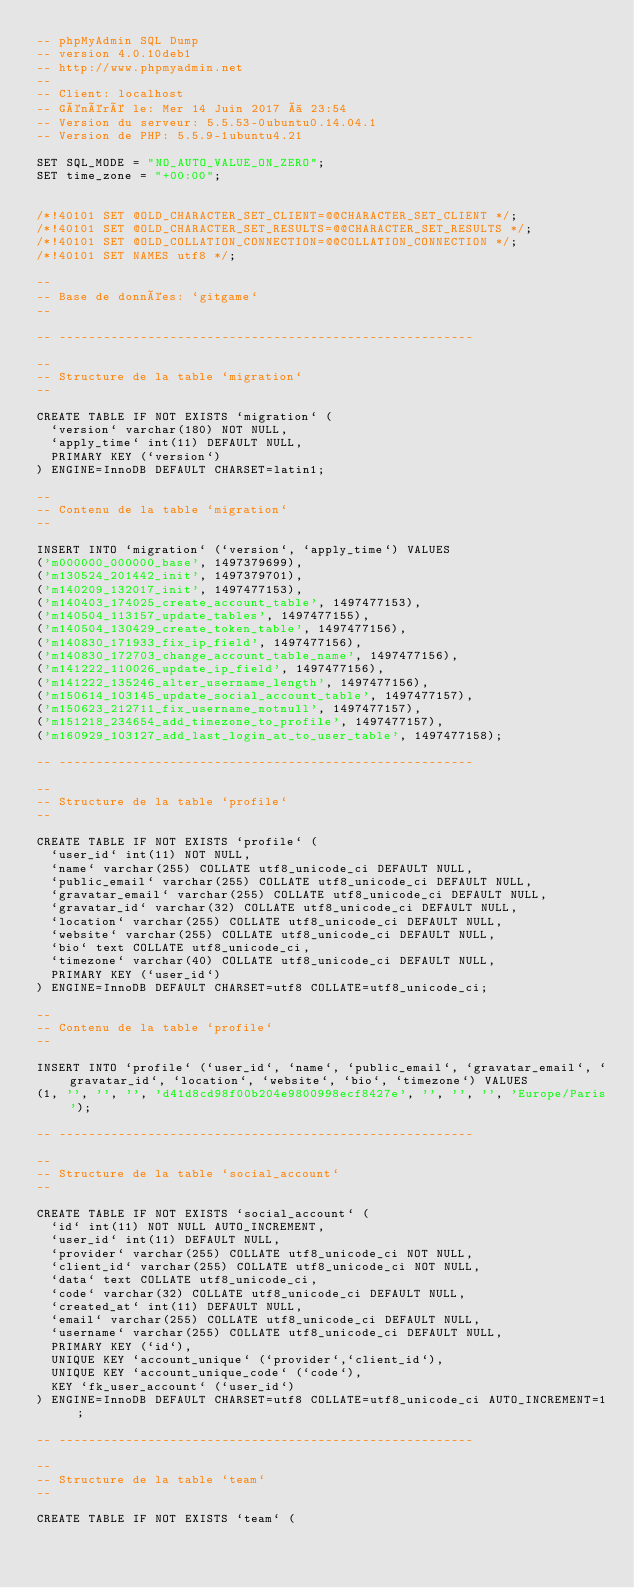<code> <loc_0><loc_0><loc_500><loc_500><_SQL_>-- phpMyAdmin SQL Dump
-- version 4.0.10deb1
-- http://www.phpmyadmin.net
--
-- Client: localhost
-- Généré le: Mer 14 Juin 2017 à 23:54
-- Version du serveur: 5.5.53-0ubuntu0.14.04.1
-- Version de PHP: 5.5.9-1ubuntu4.21

SET SQL_MODE = "NO_AUTO_VALUE_ON_ZERO";
SET time_zone = "+00:00";


/*!40101 SET @OLD_CHARACTER_SET_CLIENT=@@CHARACTER_SET_CLIENT */;
/*!40101 SET @OLD_CHARACTER_SET_RESULTS=@@CHARACTER_SET_RESULTS */;
/*!40101 SET @OLD_COLLATION_CONNECTION=@@COLLATION_CONNECTION */;
/*!40101 SET NAMES utf8 */;

--
-- Base de données: `gitgame`
--

-- --------------------------------------------------------

--
-- Structure de la table `migration`
--

CREATE TABLE IF NOT EXISTS `migration` (
  `version` varchar(180) NOT NULL,
  `apply_time` int(11) DEFAULT NULL,
  PRIMARY KEY (`version`)
) ENGINE=InnoDB DEFAULT CHARSET=latin1;

--
-- Contenu de la table `migration`
--

INSERT INTO `migration` (`version`, `apply_time`) VALUES
('m000000_000000_base', 1497379699),
('m130524_201442_init', 1497379701),
('m140209_132017_init', 1497477153),
('m140403_174025_create_account_table', 1497477153),
('m140504_113157_update_tables', 1497477155),
('m140504_130429_create_token_table', 1497477156),
('m140830_171933_fix_ip_field', 1497477156),
('m140830_172703_change_account_table_name', 1497477156),
('m141222_110026_update_ip_field', 1497477156),
('m141222_135246_alter_username_length', 1497477156),
('m150614_103145_update_social_account_table', 1497477157),
('m150623_212711_fix_username_notnull', 1497477157),
('m151218_234654_add_timezone_to_profile', 1497477157),
('m160929_103127_add_last_login_at_to_user_table', 1497477158);

-- --------------------------------------------------------

--
-- Structure de la table `profile`
--

CREATE TABLE IF NOT EXISTS `profile` (
  `user_id` int(11) NOT NULL,
  `name` varchar(255) COLLATE utf8_unicode_ci DEFAULT NULL,
  `public_email` varchar(255) COLLATE utf8_unicode_ci DEFAULT NULL,
  `gravatar_email` varchar(255) COLLATE utf8_unicode_ci DEFAULT NULL,
  `gravatar_id` varchar(32) COLLATE utf8_unicode_ci DEFAULT NULL,
  `location` varchar(255) COLLATE utf8_unicode_ci DEFAULT NULL,
  `website` varchar(255) COLLATE utf8_unicode_ci DEFAULT NULL,
  `bio` text COLLATE utf8_unicode_ci,
  `timezone` varchar(40) COLLATE utf8_unicode_ci DEFAULT NULL,
  PRIMARY KEY (`user_id`)
) ENGINE=InnoDB DEFAULT CHARSET=utf8 COLLATE=utf8_unicode_ci;

--
-- Contenu de la table `profile`
--

INSERT INTO `profile` (`user_id`, `name`, `public_email`, `gravatar_email`, `gravatar_id`, `location`, `website`, `bio`, `timezone`) VALUES
(1, '', '', '', 'd41d8cd98f00b204e9800998ecf8427e', '', '', '', 'Europe/Paris');

-- --------------------------------------------------------

--
-- Structure de la table `social_account`
--

CREATE TABLE IF NOT EXISTS `social_account` (
  `id` int(11) NOT NULL AUTO_INCREMENT,
  `user_id` int(11) DEFAULT NULL,
  `provider` varchar(255) COLLATE utf8_unicode_ci NOT NULL,
  `client_id` varchar(255) COLLATE utf8_unicode_ci NOT NULL,
  `data` text COLLATE utf8_unicode_ci,
  `code` varchar(32) COLLATE utf8_unicode_ci DEFAULT NULL,
  `created_at` int(11) DEFAULT NULL,
  `email` varchar(255) COLLATE utf8_unicode_ci DEFAULT NULL,
  `username` varchar(255) COLLATE utf8_unicode_ci DEFAULT NULL,
  PRIMARY KEY (`id`),
  UNIQUE KEY `account_unique` (`provider`,`client_id`),
  UNIQUE KEY `account_unique_code` (`code`),
  KEY `fk_user_account` (`user_id`)
) ENGINE=InnoDB DEFAULT CHARSET=utf8 COLLATE=utf8_unicode_ci AUTO_INCREMENT=1 ;

-- --------------------------------------------------------

--
-- Structure de la table `team`
--

CREATE TABLE IF NOT EXISTS `team` (</code> 